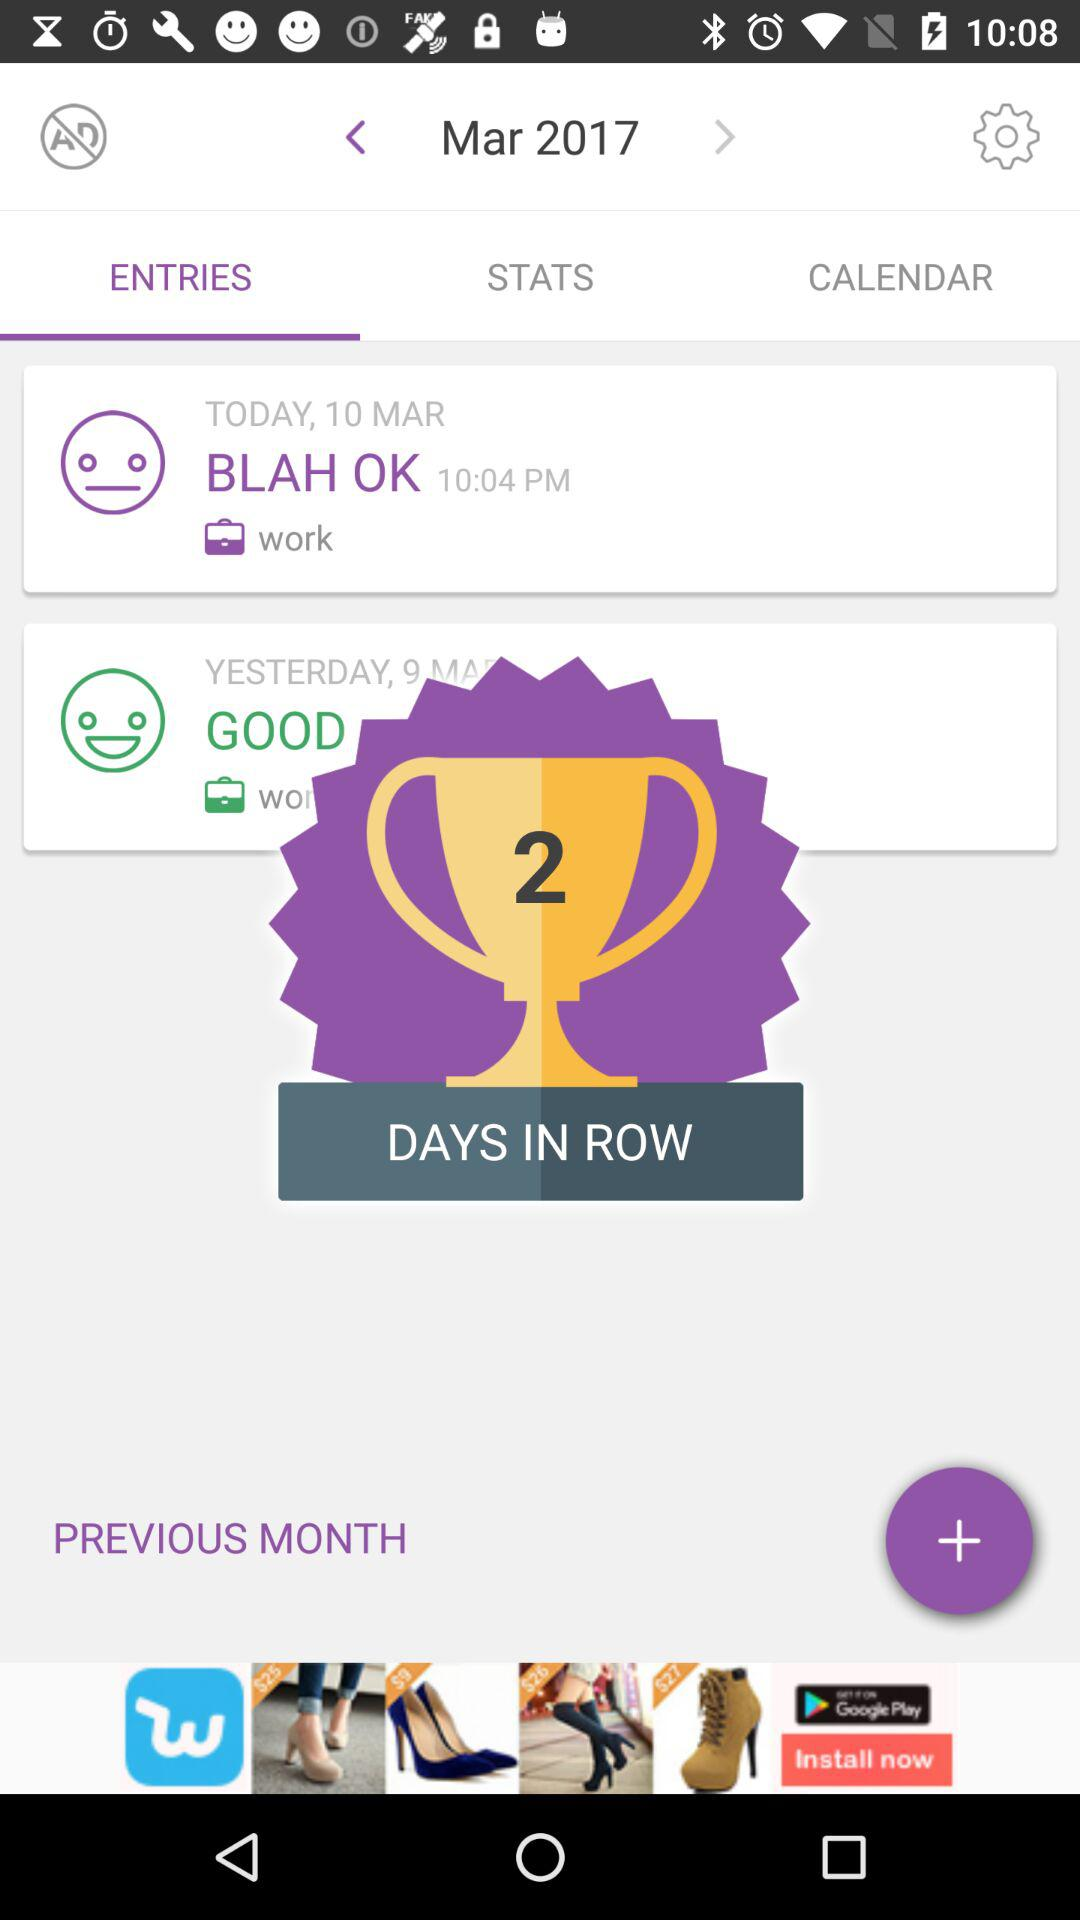How many days are in a row? There are 2 days in a row. 